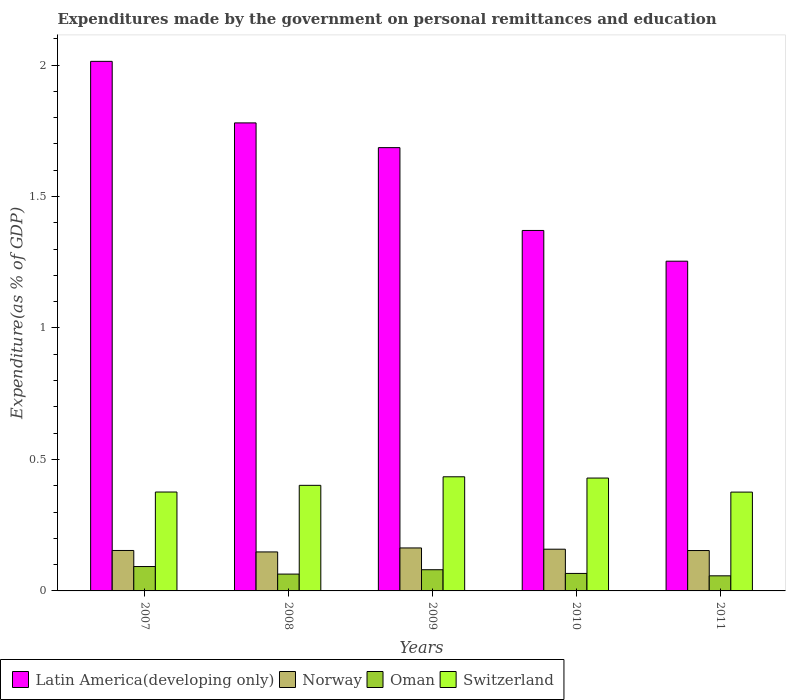How many different coloured bars are there?
Give a very brief answer. 4. How many groups of bars are there?
Provide a succinct answer. 5. Are the number of bars per tick equal to the number of legend labels?
Provide a succinct answer. Yes. What is the expenditures made by the government on personal remittances and education in Switzerland in 2007?
Ensure brevity in your answer.  0.38. Across all years, what is the maximum expenditures made by the government on personal remittances and education in Oman?
Ensure brevity in your answer.  0.09. Across all years, what is the minimum expenditures made by the government on personal remittances and education in Norway?
Provide a short and direct response. 0.15. What is the total expenditures made by the government on personal remittances and education in Norway in the graph?
Offer a terse response. 0.78. What is the difference between the expenditures made by the government on personal remittances and education in Latin America(developing only) in 2007 and that in 2011?
Ensure brevity in your answer.  0.76. What is the difference between the expenditures made by the government on personal remittances and education in Switzerland in 2007 and the expenditures made by the government on personal remittances and education in Latin America(developing only) in 2009?
Your response must be concise. -1.31. What is the average expenditures made by the government on personal remittances and education in Oman per year?
Provide a succinct answer. 0.07. In the year 2011, what is the difference between the expenditures made by the government on personal remittances and education in Norway and expenditures made by the government on personal remittances and education in Latin America(developing only)?
Make the answer very short. -1.1. What is the ratio of the expenditures made by the government on personal remittances and education in Latin America(developing only) in 2010 to that in 2011?
Your answer should be very brief. 1.09. Is the expenditures made by the government on personal remittances and education in Latin America(developing only) in 2009 less than that in 2010?
Your answer should be very brief. No. What is the difference between the highest and the second highest expenditures made by the government on personal remittances and education in Oman?
Ensure brevity in your answer.  0.01. What is the difference between the highest and the lowest expenditures made by the government on personal remittances and education in Latin America(developing only)?
Keep it short and to the point. 0.76. Is it the case that in every year, the sum of the expenditures made by the government on personal remittances and education in Norway and expenditures made by the government on personal remittances and education in Oman is greater than the sum of expenditures made by the government on personal remittances and education in Switzerland and expenditures made by the government on personal remittances and education in Latin America(developing only)?
Keep it short and to the point. No. What does the 4th bar from the right in 2011 represents?
Your answer should be very brief. Latin America(developing only). Is it the case that in every year, the sum of the expenditures made by the government on personal remittances and education in Latin America(developing only) and expenditures made by the government on personal remittances and education in Switzerland is greater than the expenditures made by the government on personal remittances and education in Norway?
Provide a short and direct response. Yes. How many bars are there?
Your response must be concise. 20. Are all the bars in the graph horizontal?
Offer a very short reply. No. Are the values on the major ticks of Y-axis written in scientific E-notation?
Offer a terse response. No. Does the graph contain grids?
Your answer should be very brief. No. Where does the legend appear in the graph?
Make the answer very short. Bottom left. How are the legend labels stacked?
Ensure brevity in your answer.  Horizontal. What is the title of the graph?
Provide a short and direct response. Expenditures made by the government on personal remittances and education. What is the label or title of the X-axis?
Provide a short and direct response. Years. What is the label or title of the Y-axis?
Make the answer very short. Expenditure(as % of GDP). What is the Expenditure(as % of GDP) in Latin America(developing only) in 2007?
Keep it short and to the point. 2.01. What is the Expenditure(as % of GDP) in Norway in 2007?
Ensure brevity in your answer.  0.15. What is the Expenditure(as % of GDP) of Oman in 2007?
Your response must be concise. 0.09. What is the Expenditure(as % of GDP) in Switzerland in 2007?
Provide a succinct answer. 0.38. What is the Expenditure(as % of GDP) in Latin America(developing only) in 2008?
Provide a short and direct response. 1.78. What is the Expenditure(as % of GDP) of Norway in 2008?
Your answer should be very brief. 0.15. What is the Expenditure(as % of GDP) in Oman in 2008?
Give a very brief answer. 0.06. What is the Expenditure(as % of GDP) in Switzerland in 2008?
Offer a very short reply. 0.4. What is the Expenditure(as % of GDP) in Latin America(developing only) in 2009?
Give a very brief answer. 1.69. What is the Expenditure(as % of GDP) in Norway in 2009?
Provide a short and direct response. 0.16. What is the Expenditure(as % of GDP) in Oman in 2009?
Give a very brief answer. 0.08. What is the Expenditure(as % of GDP) of Switzerland in 2009?
Offer a very short reply. 0.43. What is the Expenditure(as % of GDP) of Latin America(developing only) in 2010?
Offer a very short reply. 1.37. What is the Expenditure(as % of GDP) in Norway in 2010?
Your response must be concise. 0.16. What is the Expenditure(as % of GDP) in Oman in 2010?
Your response must be concise. 0.07. What is the Expenditure(as % of GDP) of Switzerland in 2010?
Offer a terse response. 0.43. What is the Expenditure(as % of GDP) of Latin America(developing only) in 2011?
Your answer should be very brief. 1.25. What is the Expenditure(as % of GDP) of Norway in 2011?
Offer a terse response. 0.15. What is the Expenditure(as % of GDP) of Oman in 2011?
Your answer should be compact. 0.06. What is the Expenditure(as % of GDP) of Switzerland in 2011?
Provide a short and direct response. 0.38. Across all years, what is the maximum Expenditure(as % of GDP) of Latin America(developing only)?
Give a very brief answer. 2.01. Across all years, what is the maximum Expenditure(as % of GDP) in Norway?
Ensure brevity in your answer.  0.16. Across all years, what is the maximum Expenditure(as % of GDP) in Oman?
Offer a terse response. 0.09. Across all years, what is the maximum Expenditure(as % of GDP) in Switzerland?
Your answer should be very brief. 0.43. Across all years, what is the minimum Expenditure(as % of GDP) in Latin America(developing only)?
Keep it short and to the point. 1.25. Across all years, what is the minimum Expenditure(as % of GDP) in Norway?
Offer a terse response. 0.15. Across all years, what is the minimum Expenditure(as % of GDP) of Oman?
Give a very brief answer. 0.06. Across all years, what is the minimum Expenditure(as % of GDP) of Switzerland?
Ensure brevity in your answer.  0.38. What is the total Expenditure(as % of GDP) in Latin America(developing only) in the graph?
Give a very brief answer. 8.1. What is the total Expenditure(as % of GDP) in Norway in the graph?
Provide a short and direct response. 0.78. What is the total Expenditure(as % of GDP) of Oman in the graph?
Provide a short and direct response. 0.36. What is the total Expenditure(as % of GDP) in Switzerland in the graph?
Offer a terse response. 2.02. What is the difference between the Expenditure(as % of GDP) in Latin America(developing only) in 2007 and that in 2008?
Provide a short and direct response. 0.23. What is the difference between the Expenditure(as % of GDP) in Norway in 2007 and that in 2008?
Your answer should be very brief. 0.01. What is the difference between the Expenditure(as % of GDP) in Oman in 2007 and that in 2008?
Your response must be concise. 0.03. What is the difference between the Expenditure(as % of GDP) in Switzerland in 2007 and that in 2008?
Provide a short and direct response. -0.03. What is the difference between the Expenditure(as % of GDP) of Latin America(developing only) in 2007 and that in 2009?
Provide a short and direct response. 0.33. What is the difference between the Expenditure(as % of GDP) of Norway in 2007 and that in 2009?
Make the answer very short. -0.01. What is the difference between the Expenditure(as % of GDP) in Oman in 2007 and that in 2009?
Keep it short and to the point. 0.01. What is the difference between the Expenditure(as % of GDP) in Switzerland in 2007 and that in 2009?
Ensure brevity in your answer.  -0.06. What is the difference between the Expenditure(as % of GDP) in Latin America(developing only) in 2007 and that in 2010?
Keep it short and to the point. 0.64. What is the difference between the Expenditure(as % of GDP) of Norway in 2007 and that in 2010?
Provide a short and direct response. -0. What is the difference between the Expenditure(as % of GDP) of Oman in 2007 and that in 2010?
Your response must be concise. 0.03. What is the difference between the Expenditure(as % of GDP) in Switzerland in 2007 and that in 2010?
Make the answer very short. -0.05. What is the difference between the Expenditure(as % of GDP) of Latin America(developing only) in 2007 and that in 2011?
Give a very brief answer. 0.76. What is the difference between the Expenditure(as % of GDP) in Norway in 2007 and that in 2011?
Give a very brief answer. 0. What is the difference between the Expenditure(as % of GDP) in Oman in 2007 and that in 2011?
Offer a terse response. 0.04. What is the difference between the Expenditure(as % of GDP) of Latin America(developing only) in 2008 and that in 2009?
Your response must be concise. 0.09. What is the difference between the Expenditure(as % of GDP) in Norway in 2008 and that in 2009?
Ensure brevity in your answer.  -0.02. What is the difference between the Expenditure(as % of GDP) in Oman in 2008 and that in 2009?
Your answer should be very brief. -0.02. What is the difference between the Expenditure(as % of GDP) of Switzerland in 2008 and that in 2009?
Provide a succinct answer. -0.03. What is the difference between the Expenditure(as % of GDP) of Latin America(developing only) in 2008 and that in 2010?
Your response must be concise. 0.41. What is the difference between the Expenditure(as % of GDP) in Norway in 2008 and that in 2010?
Your response must be concise. -0.01. What is the difference between the Expenditure(as % of GDP) of Oman in 2008 and that in 2010?
Keep it short and to the point. -0. What is the difference between the Expenditure(as % of GDP) in Switzerland in 2008 and that in 2010?
Make the answer very short. -0.03. What is the difference between the Expenditure(as % of GDP) in Latin America(developing only) in 2008 and that in 2011?
Keep it short and to the point. 0.53. What is the difference between the Expenditure(as % of GDP) in Norway in 2008 and that in 2011?
Keep it short and to the point. -0.01. What is the difference between the Expenditure(as % of GDP) in Oman in 2008 and that in 2011?
Ensure brevity in your answer.  0.01. What is the difference between the Expenditure(as % of GDP) in Switzerland in 2008 and that in 2011?
Give a very brief answer. 0.03. What is the difference between the Expenditure(as % of GDP) in Latin America(developing only) in 2009 and that in 2010?
Ensure brevity in your answer.  0.32. What is the difference between the Expenditure(as % of GDP) in Norway in 2009 and that in 2010?
Your answer should be compact. 0. What is the difference between the Expenditure(as % of GDP) of Oman in 2009 and that in 2010?
Offer a very short reply. 0.01. What is the difference between the Expenditure(as % of GDP) in Switzerland in 2009 and that in 2010?
Make the answer very short. 0. What is the difference between the Expenditure(as % of GDP) of Latin America(developing only) in 2009 and that in 2011?
Provide a short and direct response. 0.43. What is the difference between the Expenditure(as % of GDP) of Norway in 2009 and that in 2011?
Provide a succinct answer. 0.01. What is the difference between the Expenditure(as % of GDP) in Oman in 2009 and that in 2011?
Your answer should be very brief. 0.02. What is the difference between the Expenditure(as % of GDP) in Switzerland in 2009 and that in 2011?
Your answer should be compact. 0.06. What is the difference between the Expenditure(as % of GDP) of Latin America(developing only) in 2010 and that in 2011?
Provide a short and direct response. 0.12. What is the difference between the Expenditure(as % of GDP) in Norway in 2010 and that in 2011?
Offer a very short reply. 0.01. What is the difference between the Expenditure(as % of GDP) in Oman in 2010 and that in 2011?
Provide a short and direct response. 0.01. What is the difference between the Expenditure(as % of GDP) in Switzerland in 2010 and that in 2011?
Provide a succinct answer. 0.05. What is the difference between the Expenditure(as % of GDP) of Latin America(developing only) in 2007 and the Expenditure(as % of GDP) of Norway in 2008?
Ensure brevity in your answer.  1.87. What is the difference between the Expenditure(as % of GDP) of Latin America(developing only) in 2007 and the Expenditure(as % of GDP) of Oman in 2008?
Offer a terse response. 1.95. What is the difference between the Expenditure(as % of GDP) in Latin America(developing only) in 2007 and the Expenditure(as % of GDP) in Switzerland in 2008?
Give a very brief answer. 1.61. What is the difference between the Expenditure(as % of GDP) in Norway in 2007 and the Expenditure(as % of GDP) in Oman in 2008?
Ensure brevity in your answer.  0.09. What is the difference between the Expenditure(as % of GDP) of Norway in 2007 and the Expenditure(as % of GDP) of Switzerland in 2008?
Your answer should be very brief. -0.25. What is the difference between the Expenditure(as % of GDP) in Oman in 2007 and the Expenditure(as % of GDP) in Switzerland in 2008?
Keep it short and to the point. -0.31. What is the difference between the Expenditure(as % of GDP) in Latin America(developing only) in 2007 and the Expenditure(as % of GDP) in Norway in 2009?
Your answer should be compact. 1.85. What is the difference between the Expenditure(as % of GDP) of Latin America(developing only) in 2007 and the Expenditure(as % of GDP) of Oman in 2009?
Your response must be concise. 1.93. What is the difference between the Expenditure(as % of GDP) of Latin America(developing only) in 2007 and the Expenditure(as % of GDP) of Switzerland in 2009?
Offer a very short reply. 1.58. What is the difference between the Expenditure(as % of GDP) of Norway in 2007 and the Expenditure(as % of GDP) of Oman in 2009?
Offer a very short reply. 0.07. What is the difference between the Expenditure(as % of GDP) of Norway in 2007 and the Expenditure(as % of GDP) of Switzerland in 2009?
Give a very brief answer. -0.28. What is the difference between the Expenditure(as % of GDP) of Oman in 2007 and the Expenditure(as % of GDP) of Switzerland in 2009?
Offer a very short reply. -0.34. What is the difference between the Expenditure(as % of GDP) of Latin America(developing only) in 2007 and the Expenditure(as % of GDP) of Norway in 2010?
Keep it short and to the point. 1.86. What is the difference between the Expenditure(as % of GDP) in Latin America(developing only) in 2007 and the Expenditure(as % of GDP) in Oman in 2010?
Your answer should be very brief. 1.95. What is the difference between the Expenditure(as % of GDP) of Latin America(developing only) in 2007 and the Expenditure(as % of GDP) of Switzerland in 2010?
Offer a terse response. 1.58. What is the difference between the Expenditure(as % of GDP) of Norway in 2007 and the Expenditure(as % of GDP) of Oman in 2010?
Your answer should be compact. 0.09. What is the difference between the Expenditure(as % of GDP) of Norway in 2007 and the Expenditure(as % of GDP) of Switzerland in 2010?
Keep it short and to the point. -0.28. What is the difference between the Expenditure(as % of GDP) of Oman in 2007 and the Expenditure(as % of GDP) of Switzerland in 2010?
Provide a short and direct response. -0.34. What is the difference between the Expenditure(as % of GDP) in Latin America(developing only) in 2007 and the Expenditure(as % of GDP) in Norway in 2011?
Make the answer very short. 1.86. What is the difference between the Expenditure(as % of GDP) in Latin America(developing only) in 2007 and the Expenditure(as % of GDP) in Oman in 2011?
Provide a short and direct response. 1.96. What is the difference between the Expenditure(as % of GDP) in Latin America(developing only) in 2007 and the Expenditure(as % of GDP) in Switzerland in 2011?
Keep it short and to the point. 1.64. What is the difference between the Expenditure(as % of GDP) of Norway in 2007 and the Expenditure(as % of GDP) of Oman in 2011?
Offer a terse response. 0.1. What is the difference between the Expenditure(as % of GDP) of Norway in 2007 and the Expenditure(as % of GDP) of Switzerland in 2011?
Give a very brief answer. -0.22. What is the difference between the Expenditure(as % of GDP) of Oman in 2007 and the Expenditure(as % of GDP) of Switzerland in 2011?
Offer a very short reply. -0.28. What is the difference between the Expenditure(as % of GDP) in Latin America(developing only) in 2008 and the Expenditure(as % of GDP) in Norway in 2009?
Make the answer very short. 1.62. What is the difference between the Expenditure(as % of GDP) in Latin America(developing only) in 2008 and the Expenditure(as % of GDP) in Oman in 2009?
Keep it short and to the point. 1.7. What is the difference between the Expenditure(as % of GDP) of Latin America(developing only) in 2008 and the Expenditure(as % of GDP) of Switzerland in 2009?
Your answer should be very brief. 1.35. What is the difference between the Expenditure(as % of GDP) in Norway in 2008 and the Expenditure(as % of GDP) in Oman in 2009?
Provide a short and direct response. 0.07. What is the difference between the Expenditure(as % of GDP) of Norway in 2008 and the Expenditure(as % of GDP) of Switzerland in 2009?
Offer a terse response. -0.29. What is the difference between the Expenditure(as % of GDP) of Oman in 2008 and the Expenditure(as % of GDP) of Switzerland in 2009?
Offer a terse response. -0.37. What is the difference between the Expenditure(as % of GDP) of Latin America(developing only) in 2008 and the Expenditure(as % of GDP) of Norway in 2010?
Give a very brief answer. 1.62. What is the difference between the Expenditure(as % of GDP) of Latin America(developing only) in 2008 and the Expenditure(as % of GDP) of Oman in 2010?
Make the answer very short. 1.71. What is the difference between the Expenditure(as % of GDP) in Latin America(developing only) in 2008 and the Expenditure(as % of GDP) in Switzerland in 2010?
Give a very brief answer. 1.35. What is the difference between the Expenditure(as % of GDP) in Norway in 2008 and the Expenditure(as % of GDP) in Oman in 2010?
Your answer should be very brief. 0.08. What is the difference between the Expenditure(as % of GDP) in Norway in 2008 and the Expenditure(as % of GDP) in Switzerland in 2010?
Provide a succinct answer. -0.28. What is the difference between the Expenditure(as % of GDP) in Oman in 2008 and the Expenditure(as % of GDP) in Switzerland in 2010?
Offer a terse response. -0.37. What is the difference between the Expenditure(as % of GDP) in Latin America(developing only) in 2008 and the Expenditure(as % of GDP) in Norway in 2011?
Your response must be concise. 1.63. What is the difference between the Expenditure(as % of GDP) of Latin America(developing only) in 2008 and the Expenditure(as % of GDP) of Oman in 2011?
Your answer should be very brief. 1.72. What is the difference between the Expenditure(as % of GDP) in Latin America(developing only) in 2008 and the Expenditure(as % of GDP) in Switzerland in 2011?
Ensure brevity in your answer.  1.4. What is the difference between the Expenditure(as % of GDP) in Norway in 2008 and the Expenditure(as % of GDP) in Oman in 2011?
Keep it short and to the point. 0.09. What is the difference between the Expenditure(as % of GDP) of Norway in 2008 and the Expenditure(as % of GDP) of Switzerland in 2011?
Provide a succinct answer. -0.23. What is the difference between the Expenditure(as % of GDP) in Oman in 2008 and the Expenditure(as % of GDP) in Switzerland in 2011?
Keep it short and to the point. -0.31. What is the difference between the Expenditure(as % of GDP) of Latin America(developing only) in 2009 and the Expenditure(as % of GDP) of Norway in 2010?
Offer a very short reply. 1.53. What is the difference between the Expenditure(as % of GDP) in Latin America(developing only) in 2009 and the Expenditure(as % of GDP) in Oman in 2010?
Keep it short and to the point. 1.62. What is the difference between the Expenditure(as % of GDP) in Latin America(developing only) in 2009 and the Expenditure(as % of GDP) in Switzerland in 2010?
Make the answer very short. 1.26. What is the difference between the Expenditure(as % of GDP) of Norway in 2009 and the Expenditure(as % of GDP) of Oman in 2010?
Keep it short and to the point. 0.1. What is the difference between the Expenditure(as % of GDP) in Norway in 2009 and the Expenditure(as % of GDP) in Switzerland in 2010?
Keep it short and to the point. -0.27. What is the difference between the Expenditure(as % of GDP) of Oman in 2009 and the Expenditure(as % of GDP) of Switzerland in 2010?
Your response must be concise. -0.35. What is the difference between the Expenditure(as % of GDP) in Latin America(developing only) in 2009 and the Expenditure(as % of GDP) in Norway in 2011?
Your answer should be very brief. 1.53. What is the difference between the Expenditure(as % of GDP) in Latin America(developing only) in 2009 and the Expenditure(as % of GDP) in Oman in 2011?
Make the answer very short. 1.63. What is the difference between the Expenditure(as % of GDP) of Latin America(developing only) in 2009 and the Expenditure(as % of GDP) of Switzerland in 2011?
Offer a terse response. 1.31. What is the difference between the Expenditure(as % of GDP) of Norway in 2009 and the Expenditure(as % of GDP) of Oman in 2011?
Give a very brief answer. 0.11. What is the difference between the Expenditure(as % of GDP) of Norway in 2009 and the Expenditure(as % of GDP) of Switzerland in 2011?
Provide a short and direct response. -0.21. What is the difference between the Expenditure(as % of GDP) of Oman in 2009 and the Expenditure(as % of GDP) of Switzerland in 2011?
Your response must be concise. -0.3. What is the difference between the Expenditure(as % of GDP) in Latin America(developing only) in 2010 and the Expenditure(as % of GDP) in Norway in 2011?
Offer a terse response. 1.22. What is the difference between the Expenditure(as % of GDP) in Latin America(developing only) in 2010 and the Expenditure(as % of GDP) in Oman in 2011?
Your answer should be compact. 1.31. What is the difference between the Expenditure(as % of GDP) of Norway in 2010 and the Expenditure(as % of GDP) of Oman in 2011?
Keep it short and to the point. 0.1. What is the difference between the Expenditure(as % of GDP) in Norway in 2010 and the Expenditure(as % of GDP) in Switzerland in 2011?
Keep it short and to the point. -0.22. What is the difference between the Expenditure(as % of GDP) of Oman in 2010 and the Expenditure(as % of GDP) of Switzerland in 2011?
Make the answer very short. -0.31. What is the average Expenditure(as % of GDP) of Latin America(developing only) per year?
Give a very brief answer. 1.62. What is the average Expenditure(as % of GDP) in Norway per year?
Give a very brief answer. 0.16. What is the average Expenditure(as % of GDP) in Oman per year?
Make the answer very short. 0.07. What is the average Expenditure(as % of GDP) in Switzerland per year?
Keep it short and to the point. 0.4. In the year 2007, what is the difference between the Expenditure(as % of GDP) in Latin America(developing only) and Expenditure(as % of GDP) in Norway?
Ensure brevity in your answer.  1.86. In the year 2007, what is the difference between the Expenditure(as % of GDP) in Latin America(developing only) and Expenditure(as % of GDP) in Oman?
Provide a succinct answer. 1.92. In the year 2007, what is the difference between the Expenditure(as % of GDP) in Latin America(developing only) and Expenditure(as % of GDP) in Switzerland?
Ensure brevity in your answer.  1.64. In the year 2007, what is the difference between the Expenditure(as % of GDP) of Norway and Expenditure(as % of GDP) of Oman?
Offer a very short reply. 0.06. In the year 2007, what is the difference between the Expenditure(as % of GDP) of Norway and Expenditure(as % of GDP) of Switzerland?
Your response must be concise. -0.22. In the year 2007, what is the difference between the Expenditure(as % of GDP) of Oman and Expenditure(as % of GDP) of Switzerland?
Offer a terse response. -0.28. In the year 2008, what is the difference between the Expenditure(as % of GDP) in Latin America(developing only) and Expenditure(as % of GDP) in Norway?
Provide a succinct answer. 1.63. In the year 2008, what is the difference between the Expenditure(as % of GDP) of Latin America(developing only) and Expenditure(as % of GDP) of Oman?
Provide a succinct answer. 1.72. In the year 2008, what is the difference between the Expenditure(as % of GDP) in Latin America(developing only) and Expenditure(as % of GDP) in Switzerland?
Offer a terse response. 1.38. In the year 2008, what is the difference between the Expenditure(as % of GDP) of Norway and Expenditure(as % of GDP) of Oman?
Make the answer very short. 0.08. In the year 2008, what is the difference between the Expenditure(as % of GDP) in Norway and Expenditure(as % of GDP) in Switzerland?
Ensure brevity in your answer.  -0.25. In the year 2008, what is the difference between the Expenditure(as % of GDP) of Oman and Expenditure(as % of GDP) of Switzerland?
Your answer should be very brief. -0.34. In the year 2009, what is the difference between the Expenditure(as % of GDP) of Latin America(developing only) and Expenditure(as % of GDP) of Norway?
Give a very brief answer. 1.52. In the year 2009, what is the difference between the Expenditure(as % of GDP) in Latin America(developing only) and Expenditure(as % of GDP) in Oman?
Provide a short and direct response. 1.61. In the year 2009, what is the difference between the Expenditure(as % of GDP) in Latin America(developing only) and Expenditure(as % of GDP) in Switzerland?
Your answer should be very brief. 1.25. In the year 2009, what is the difference between the Expenditure(as % of GDP) in Norway and Expenditure(as % of GDP) in Oman?
Provide a short and direct response. 0.08. In the year 2009, what is the difference between the Expenditure(as % of GDP) of Norway and Expenditure(as % of GDP) of Switzerland?
Keep it short and to the point. -0.27. In the year 2009, what is the difference between the Expenditure(as % of GDP) of Oman and Expenditure(as % of GDP) of Switzerland?
Offer a very short reply. -0.35. In the year 2010, what is the difference between the Expenditure(as % of GDP) of Latin America(developing only) and Expenditure(as % of GDP) of Norway?
Keep it short and to the point. 1.21. In the year 2010, what is the difference between the Expenditure(as % of GDP) of Latin America(developing only) and Expenditure(as % of GDP) of Oman?
Your answer should be compact. 1.3. In the year 2010, what is the difference between the Expenditure(as % of GDP) of Latin America(developing only) and Expenditure(as % of GDP) of Switzerland?
Offer a very short reply. 0.94. In the year 2010, what is the difference between the Expenditure(as % of GDP) in Norway and Expenditure(as % of GDP) in Oman?
Ensure brevity in your answer.  0.09. In the year 2010, what is the difference between the Expenditure(as % of GDP) in Norway and Expenditure(as % of GDP) in Switzerland?
Provide a short and direct response. -0.27. In the year 2010, what is the difference between the Expenditure(as % of GDP) in Oman and Expenditure(as % of GDP) in Switzerland?
Keep it short and to the point. -0.36. In the year 2011, what is the difference between the Expenditure(as % of GDP) in Latin America(developing only) and Expenditure(as % of GDP) in Norway?
Provide a succinct answer. 1.1. In the year 2011, what is the difference between the Expenditure(as % of GDP) in Latin America(developing only) and Expenditure(as % of GDP) in Oman?
Make the answer very short. 1.2. In the year 2011, what is the difference between the Expenditure(as % of GDP) of Latin America(developing only) and Expenditure(as % of GDP) of Switzerland?
Make the answer very short. 0.88. In the year 2011, what is the difference between the Expenditure(as % of GDP) in Norway and Expenditure(as % of GDP) in Oman?
Give a very brief answer. 0.1. In the year 2011, what is the difference between the Expenditure(as % of GDP) in Norway and Expenditure(as % of GDP) in Switzerland?
Offer a very short reply. -0.22. In the year 2011, what is the difference between the Expenditure(as % of GDP) of Oman and Expenditure(as % of GDP) of Switzerland?
Your response must be concise. -0.32. What is the ratio of the Expenditure(as % of GDP) of Latin America(developing only) in 2007 to that in 2008?
Provide a succinct answer. 1.13. What is the ratio of the Expenditure(as % of GDP) of Norway in 2007 to that in 2008?
Give a very brief answer. 1.04. What is the ratio of the Expenditure(as % of GDP) of Oman in 2007 to that in 2008?
Keep it short and to the point. 1.45. What is the ratio of the Expenditure(as % of GDP) of Switzerland in 2007 to that in 2008?
Offer a terse response. 0.94. What is the ratio of the Expenditure(as % of GDP) in Latin America(developing only) in 2007 to that in 2009?
Offer a terse response. 1.19. What is the ratio of the Expenditure(as % of GDP) of Norway in 2007 to that in 2009?
Offer a very short reply. 0.94. What is the ratio of the Expenditure(as % of GDP) in Oman in 2007 to that in 2009?
Ensure brevity in your answer.  1.15. What is the ratio of the Expenditure(as % of GDP) of Switzerland in 2007 to that in 2009?
Give a very brief answer. 0.87. What is the ratio of the Expenditure(as % of GDP) in Latin America(developing only) in 2007 to that in 2010?
Give a very brief answer. 1.47. What is the ratio of the Expenditure(as % of GDP) in Norway in 2007 to that in 2010?
Keep it short and to the point. 0.97. What is the ratio of the Expenditure(as % of GDP) in Oman in 2007 to that in 2010?
Your answer should be very brief. 1.39. What is the ratio of the Expenditure(as % of GDP) in Switzerland in 2007 to that in 2010?
Make the answer very short. 0.88. What is the ratio of the Expenditure(as % of GDP) of Latin America(developing only) in 2007 to that in 2011?
Your response must be concise. 1.61. What is the ratio of the Expenditure(as % of GDP) in Oman in 2007 to that in 2011?
Provide a succinct answer. 1.61. What is the ratio of the Expenditure(as % of GDP) of Switzerland in 2007 to that in 2011?
Your response must be concise. 1. What is the ratio of the Expenditure(as % of GDP) of Latin America(developing only) in 2008 to that in 2009?
Offer a terse response. 1.06. What is the ratio of the Expenditure(as % of GDP) of Norway in 2008 to that in 2009?
Make the answer very short. 0.91. What is the ratio of the Expenditure(as % of GDP) in Oman in 2008 to that in 2009?
Your answer should be compact. 0.79. What is the ratio of the Expenditure(as % of GDP) of Switzerland in 2008 to that in 2009?
Keep it short and to the point. 0.93. What is the ratio of the Expenditure(as % of GDP) of Latin America(developing only) in 2008 to that in 2010?
Provide a short and direct response. 1.3. What is the ratio of the Expenditure(as % of GDP) in Norway in 2008 to that in 2010?
Your answer should be compact. 0.93. What is the ratio of the Expenditure(as % of GDP) of Oman in 2008 to that in 2010?
Offer a very short reply. 0.96. What is the ratio of the Expenditure(as % of GDP) of Switzerland in 2008 to that in 2010?
Your answer should be very brief. 0.94. What is the ratio of the Expenditure(as % of GDP) in Latin America(developing only) in 2008 to that in 2011?
Provide a succinct answer. 1.42. What is the ratio of the Expenditure(as % of GDP) in Norway in 2008 to that in 2011?
Make the answer very short. 0.97. What is the ratio of the Expenditure(as % of GDP) in Oman in 2008 to that in 2011?
Offer a very short reply. 1.12. What is the ratio of the Expenditure(as % of GDP) in Switzerland in 2008 to that in 2011?
Make the answer very short. 1.07. What is the ratio of the Expenditure(as % of GDP) in Latin America(developing only) in 2009 to that in 2010?
Offer a very short reply. 1.23. What is the ratio of the Expenditure(as % of GDP) in Oman in 2009 to that in 2010?
Give a very brief answer. 1.21. What is the ratio of the Expenditure(as % of GDP) in Switzerland in 2009 to that in 2010?
Your answer should be compact. 1.01. What is the ratio of the Expenditure(as % of GDP) in Latin America(developing only) in 2009 to that in 2011?
Provide a succinct answer. 1.34. What is the ratio of the Expenditure(as % of GDP) of Norway in 2009 to that in 2011?
Your answer should be very brief. 1.06. What is the ratio of the Expenditure(as % of GDP) of Oman in 2009 to that in 2011?
Provide a short and direct response. 1.4. What is the ratio of the Expenditure(as % of GDP) in Switzerland in 2009 to that in 2011?
Ensure brevity in your answer.  1.15. What is the ratio of the Expenditure(as % of GDP) in Latin America(developing only) in 2010 to that in 2011?
Make the answer very short. 1.09. What is the ratio of the Expenditure(as % of GDP) of Norway in 2010 to that in 2011?
Your answer should be very brief. 1.03. What is the ratio of the Expenditure(as % of GDP) in Oman in 2010 to that in 2011?
Offer a very short reply. 1.16. What is the ratio of the Expenditure(as % of GDP) of Switzerland in 2010 to that in 2011?
Your response must be concise. 1.14. What is the difference between the highest and the second highest Expenditure(as % of GDP) in Latin America(developing only)?
Your answer should be compact. 0.23. What is the difference between the highest and the second highest Expenditure(as % of GDP) in Norway?
Provide a short and direct response. 0. What is the difference between the highest and the second highest Expenditure(as % of GDP) of Oman?
Give a very brief answer. 0.01. What is the difference between the highest and the second highest Expenditure(as % of GDP) of Switzerland?
Your response must be concise. 0. What is the difference between the highest and the lowest Expenditure(as % of GDP) in Latin America(developing only)?
Your answer should be very brief. 0.76. What is the difference between the highest and the lowest Expenditure(as % of GDP) of Norway?
Keep it short and to the point. 0.02. What is the difference between the highest and the lowest Expenditure(as % of GDP) in Oman?
Provide a short and direct response. 0.04. What is the difference between the highest and the lowest Expenditure(as % of GDP) of Switzerland?
Ensure brevity in your answer.  0.06. 